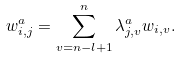<formula> <loc_0><loc_0><loc_500><loc_500>w ^ { a } _ { i , j } = \sum _ { v = n - l + 1 } ^ { n } \lambda ^ { a } _ { j , v } w _ { i , v } .</formula> 